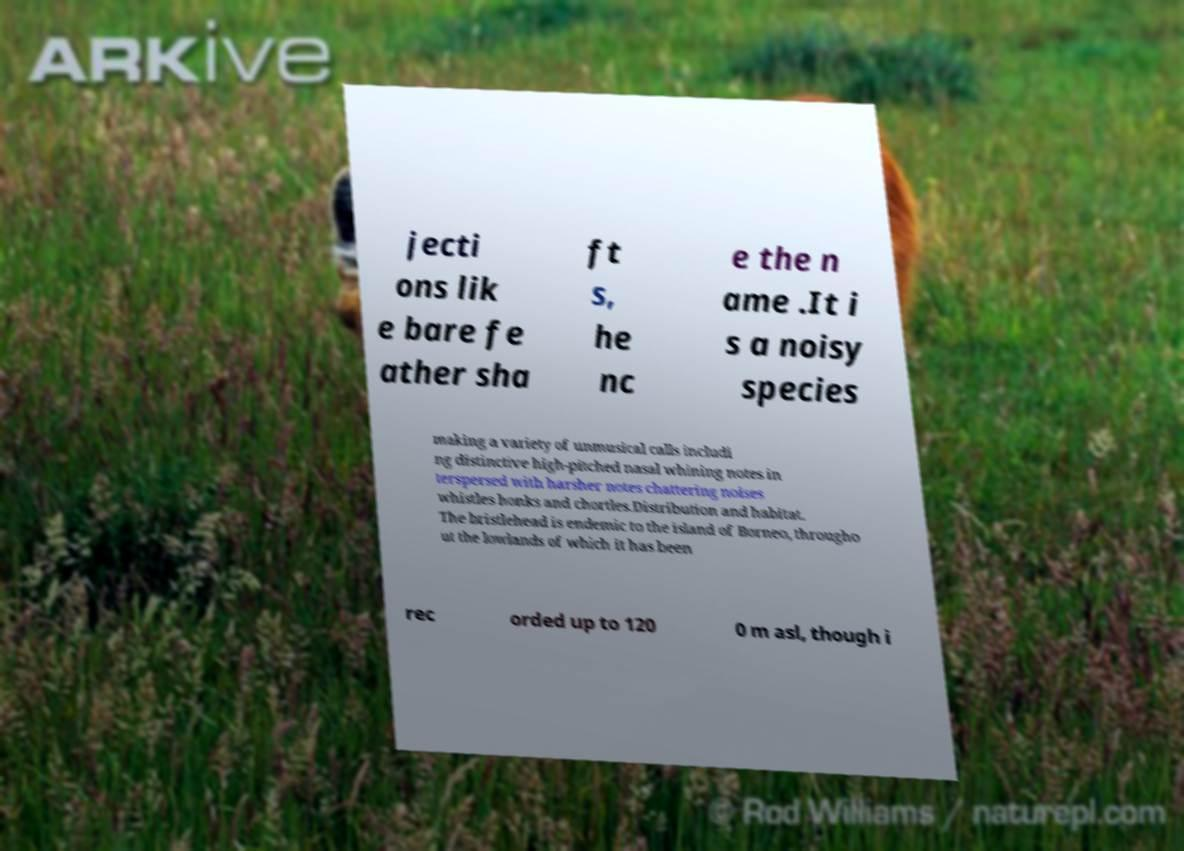There's text embedded in this image that I need extracted. Can you transcribe it verbatim? jecti ons lik e bare fe ather sha ft s, he nc e the n ame .It i s a noisy species making a variety of unmusical calls includi ng distinctive high-pitched nasal whining notes in terspersed with harsher notes chattering noises whistles honks and chortles.Distribution and habitat. The bristlehead is endemic to the island of Borneo, througho ut the lowlands of which it has been rec orded up to 120 0 m asl, though i 